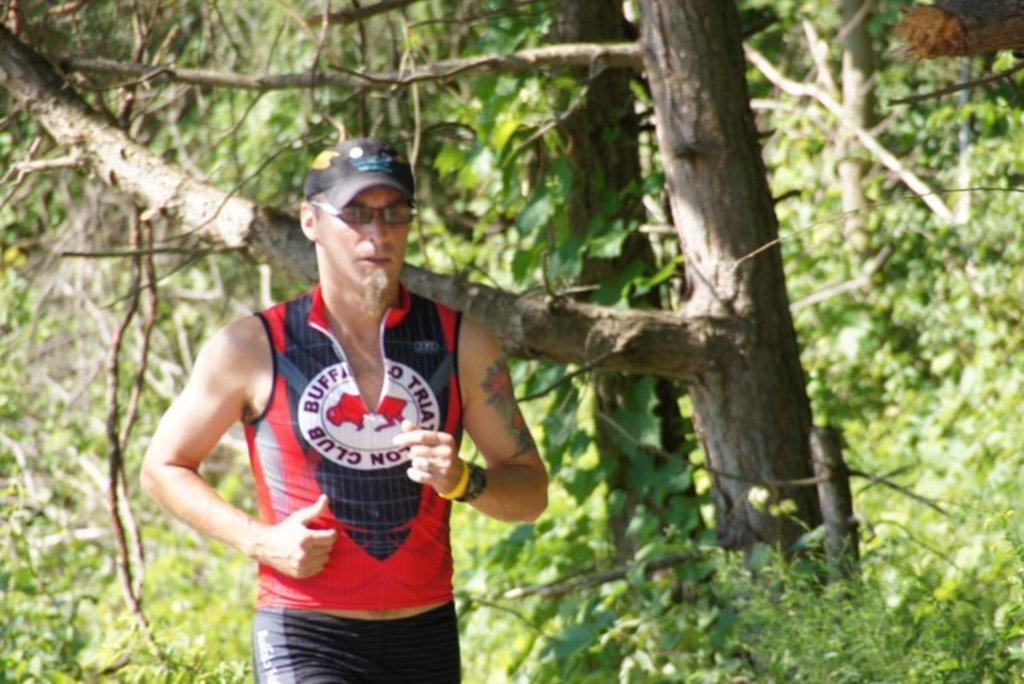What is the full name of the club on the shirt?
Provide a succinct answer. Buffalo triathalon club. 